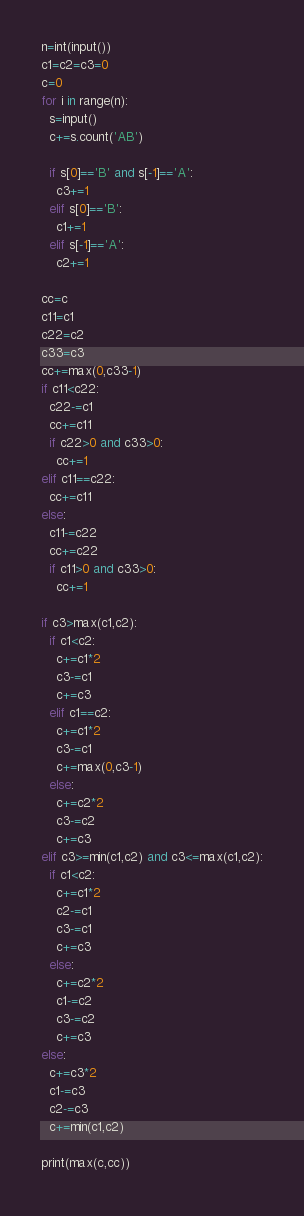<code> <loc_0><loc_0><loc_500><loc_500><_Python_>n=int(input())
c1=c2=c3=0
c=0
for i in range(n):
  s=input()
  c+=s.count('AB')

  if s[0]=='B' and s[-1]=='A':
    c3+=1
  elif s[0]=='B':
    c1+=1
  elif s[-1]=='A':
    c2+=1

cc=c
c11=c1
c22=c2
c33=c3
cc+=max(0,c33-1)
if c11<c22:
  c22-=c1
  cc+=c11
  if c22>0 and c33>0:
    cc+=1
elif c11==c22:
  cc+=c11
else:
  c11-=c22
  cc+=c22
  if c11>0 and c33>0:
    cc+=1

if c3>max(c1,c2):
  if c1<c2:
    c+=c1*2
    c3-=c1
    c+=c3
  elif c1==c2:
    c+=c1*2
    c3-=c1
    c+=max(0,c3-1)
  else:
    c+=c2*2
    c3-=c2
    c+=c3
elif c3>=min(c1,c2) and c3<=max(c1,c2):
  if c1<c2:
    c+=c1*2
    c2-=c1
    c3-=c1
    c+=c3
  else:
    c+=c2*2
    c1-=c2
    c3-=c2
    c+=c3
else:
  c+=c3*2
  c1-=c3
  c2-=c3
  c+=min(c1,c2)

print(max(c,cc))</code> 